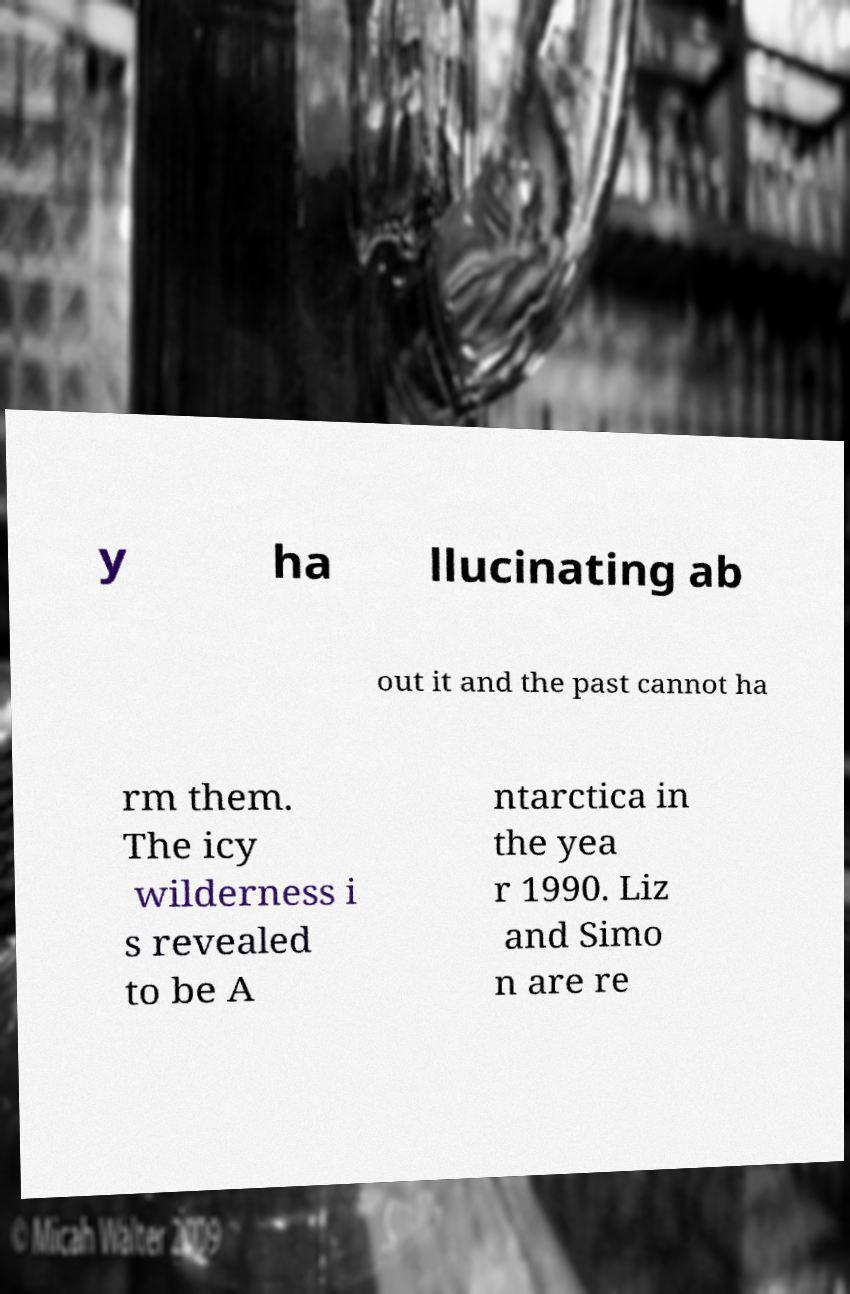Could you assist in decoding the text presented in this image and type it out clearly? y ha llucinating ab out it and the past cannot ha rm them. The icy wilderness i s revealed to be A ntarctica in the yea r 1990. Liz and Simo n are re 